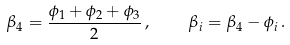Convert formula to latex. <formula><loc_0><loc_0><loc_500><loc_500>\beta _ { 4 } = \frac { \phi _ { 1 } + \phi _ { 2 } + \phi _ { 3 } } { 2 } \, , \quad \beta _ { i } = \beta _ { 4 } - \phi _ { i } \, .</formula> 